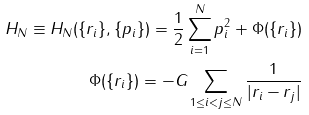Convert formula to latex. <formula><loc_0><loc_0><loc_500><loc_500>H _ { N } \equiv H _ { N } ( \{ r _ { i } \} , \{ p _ { i } \} ) = \frac { 1 } { 2 } \sum _ { i = 1 } ^ { N } p _ { i } ^ { 2 } + \Phi ( \{ r _ { i } \} ) \\ \Phi ( \{ r _ { i } \} ) = - G \sum _ { 1 \leq i < j \leq N } \frac { 1 } { | r _ { i } - r _ { j } | }</formula> 